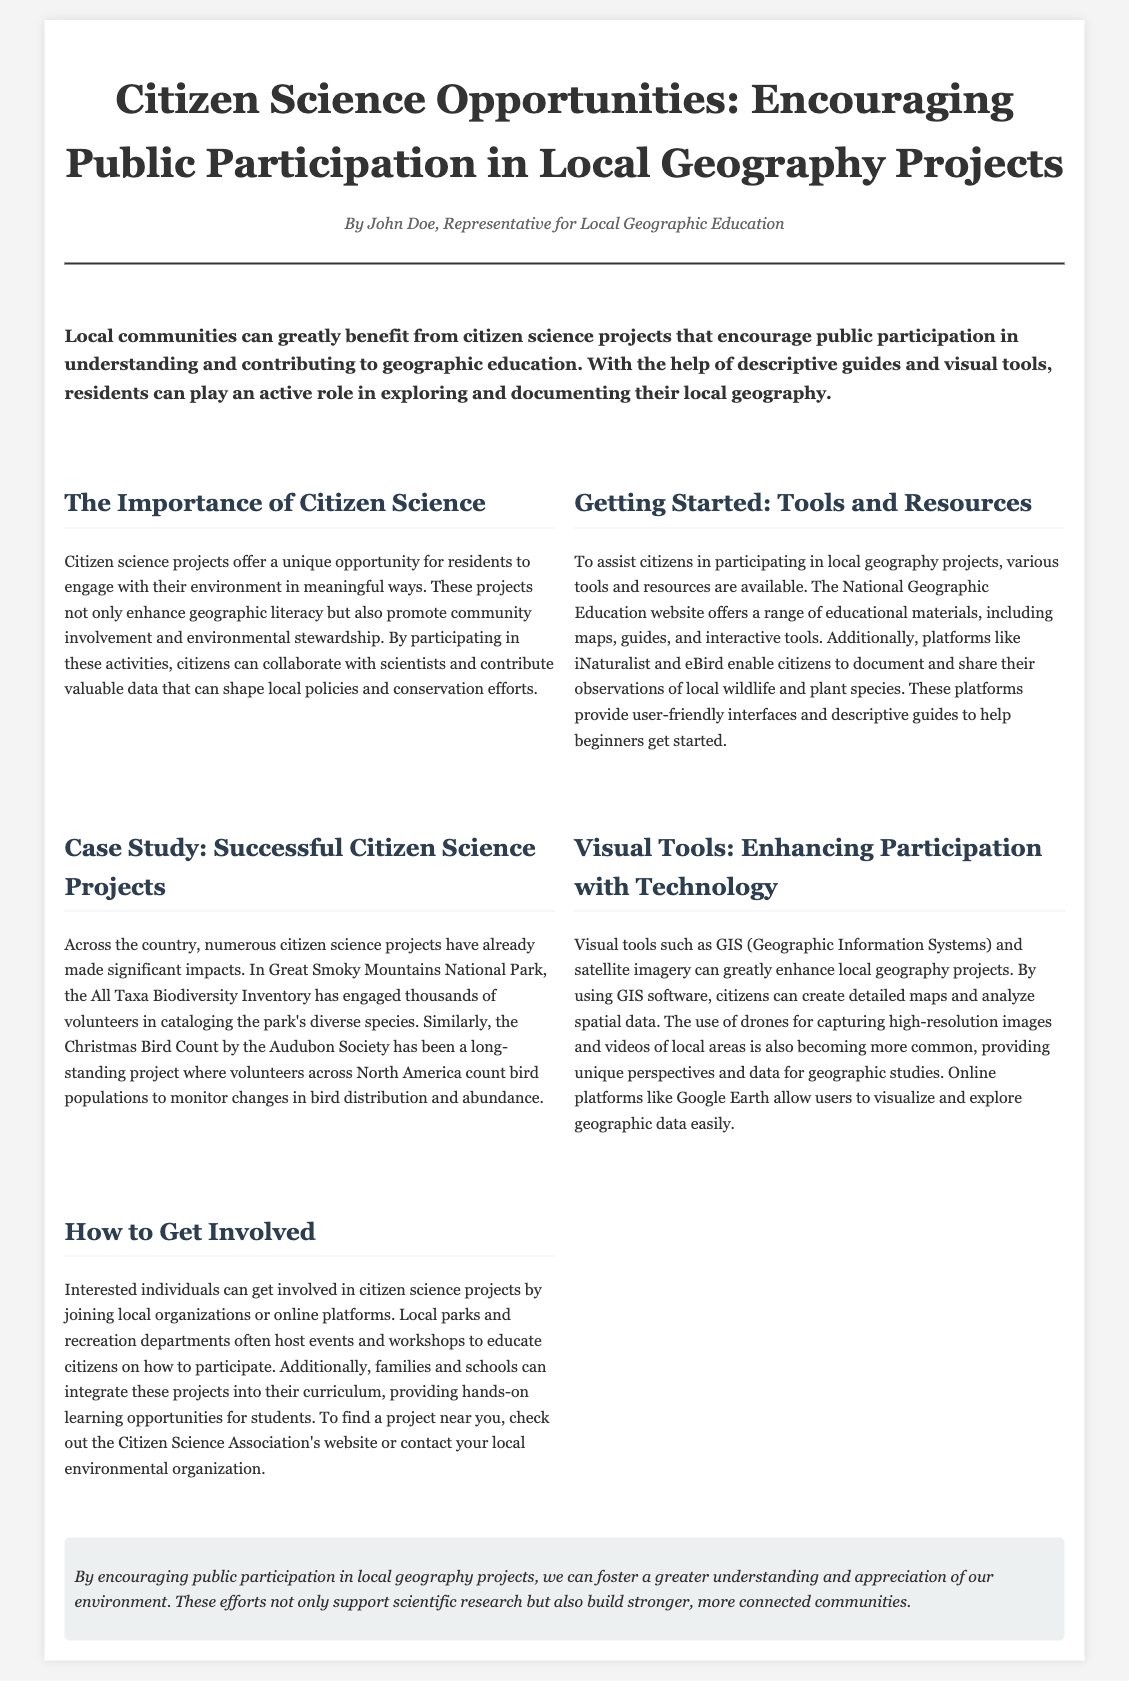What is the title of the article? The title is specifically stated at the beginning of the document and is "Citizen Science Opportunities: Encouraging Public Participation in Local Geography Projects."
Answer: Citizen Science Opportunities: Encouraging Public Participation in Local Geography Projects Who is the author of the article? The author is mentioned in the byline, which provides their name as the representative for local geographic education.
Answer: John Doe What is one platform mentioned for documenting wildlife? The document lists platforms that assist citizens in documenting wildlife, with one explicitly named being iNaturalist.
Answer: iNaturalist What is a successful case study mentioned in the document? The document highlights specific projects as case studies, and one of them is the All Taxa Biodiversity Inventory.
Answer: All Taxa Biodiversity Inventory Which tool is suggested for creating detailed maps? The document refers to GIS (Geographic Information Systems) as a tool for creating detailed maps.
Answer: GIS How can individuals find projects near them? The document advises consulting the Citizen Science Association's website to find projects nearby.
Answer: Citizen Science Association's website What do citizen science projects enhance according to the document? The document states that these projects enhance geographic literacy among participants.
Answer: Geographic literacy What is a visual tool that enhances local geography projects? The document mentions several visual tools, and one key example is satellite imagery.
Answer: Satellite imagery 